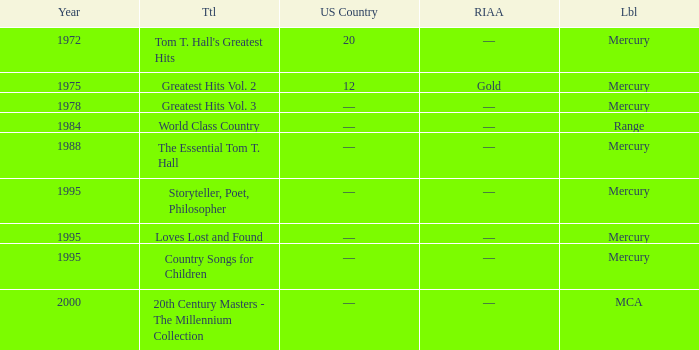What is the highest year for the title, "loves lost and found"? 1995.0. Would you mind parsing the complete table? {'header': ['Year', 'Ttl', 'US Country', 'RIAA', 'Lbl'], 'rows': [['1972', "Tom T. Hall's Greatest Hits", '20', '—', 'Mercury'], ['1975', 'Greatest Hits Vol. 2', '12', 'Gold', 'Mercury'], ['1978', 'Greatest Hits Vol. 3', '—', '—', 'Mercury'], ['1984', 'World Class Country', '—', '—', 'Range'], ['1988', 'The Essential Tom T. Hall', '—', '—', 'Mercury'], ['1995', 'Storyteller, Poet, Philosopher', '—', '—', 'Mercury'], ['1995', 'Loves Lost and Found', '—', '—', 'Mercury'], ['1995', 'Country Songs for Children', '—', '—', 'Mercury'], ['2000', '20th Century Masters - The Millennium Collection', '—', '—', 'MCA']]} 